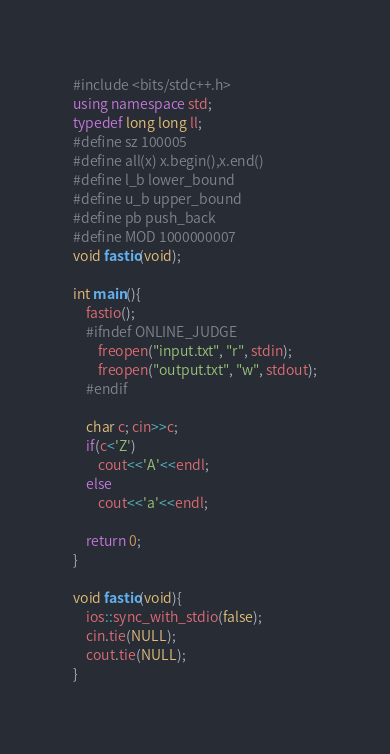<code> <loc_0><loc_0><loc_500><loc_500><_C++_>#include <bits/stdc++.h>
using namespace std;
typedef long long ll;
#define sz 100005
#define all(x) x.begin(),x.end()
#define l_b lower_bound
#define u_b upper_bound
#define pb push_back
#define MOD 1000000007
void fastio(void);

int main(){
    fastio();
    #ifndef ONLINE_JUDGE
        freopen("input.txt", "r", stdin);
        freopen("output.txt", "w", stdout);
    #endif

    char c; cin>>c;
    if(c<'Z')
        cout<<'A'<<endl;
    else
        cout<<'a'<<endl;

    return 0;
}

void fastio(void){
    ios::sync_with_stdio(false);
    cin.tie(NULL);
    cout.tie(NULL);
}</code> 